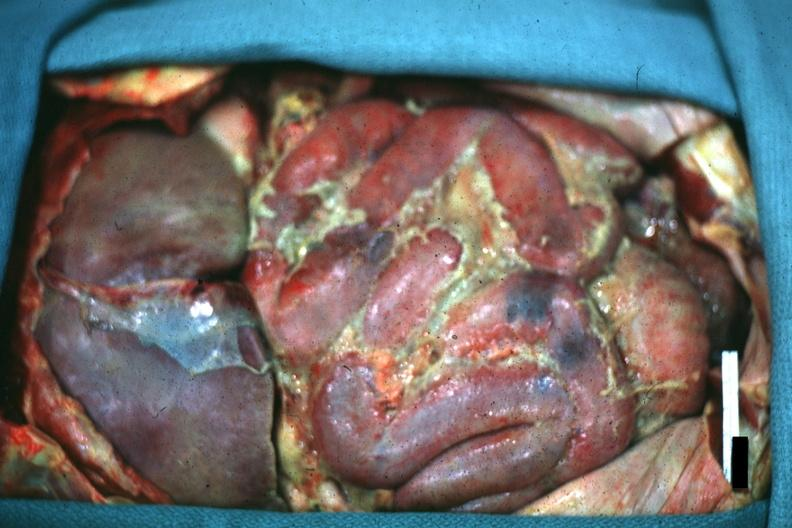does this image show opened peritoneum with fibrinopurulent peritonitis?
Answer the question using a single word or phrase. Yes 